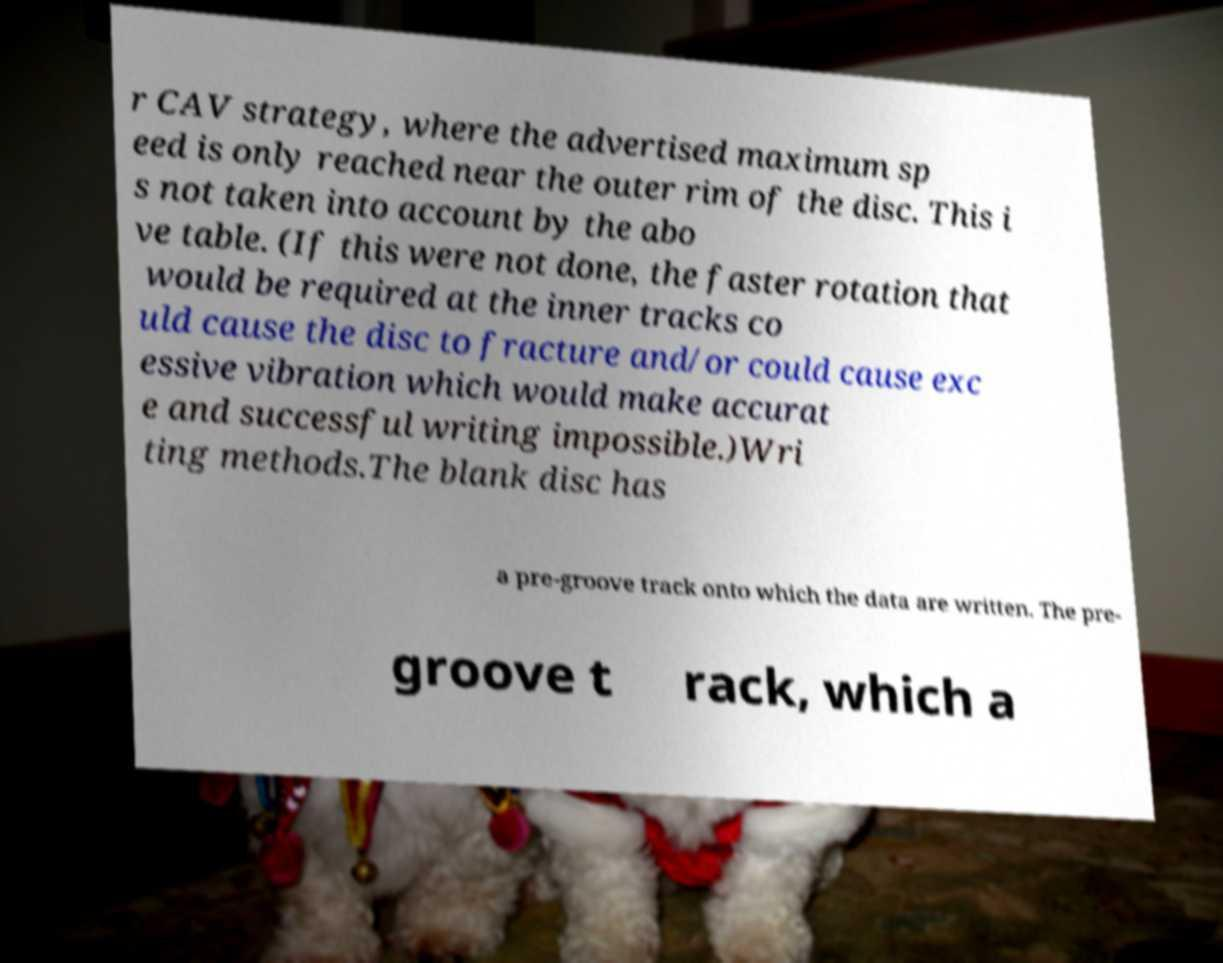Could you assist in decoding the text presented in this image and type it out clearly? r CAV strategy, where the advertised maximum sp eed is only reached near the outer rim of the disc. This i s not taken into account by the abo ve table. (If this were not done, the faster rotation that would be required at the inner tracks co uld cause the disc to fracture and/or could cause exc essive vibration which would make accurat e and successful writing impossible.)Wri ting methods.The blank disc has a pre-groove track onto which the data are written. The pre- groove t rack, which a 